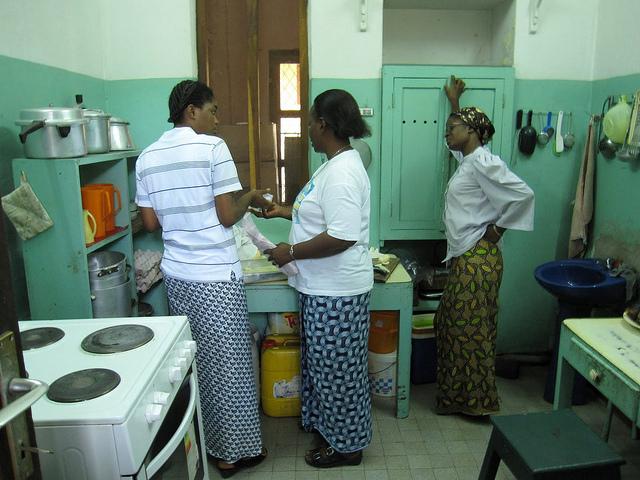What room is this?
Short answer required. Kitchen. What is hanging from the man's apron?
Short answer required. Nothing. What color is the wall in the background?
Write a very short answer. Green. Are these women wearing pants?
Give a very brief answer. No. Where are they?
Be succinct. Kitchen. What color is the sink?
Concise answer only. Blue. 